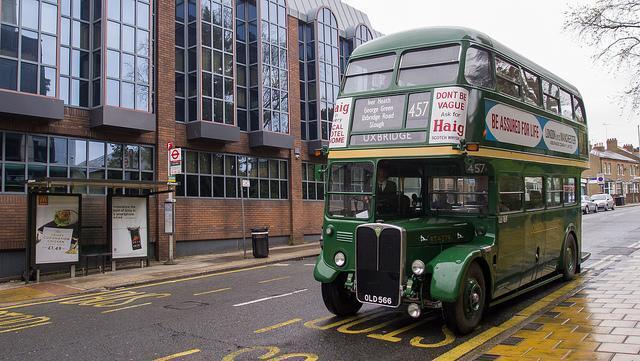How many buses are there?
Give a very brief answer. 1. How many horses are there?
Give a very brief answer. 0. 